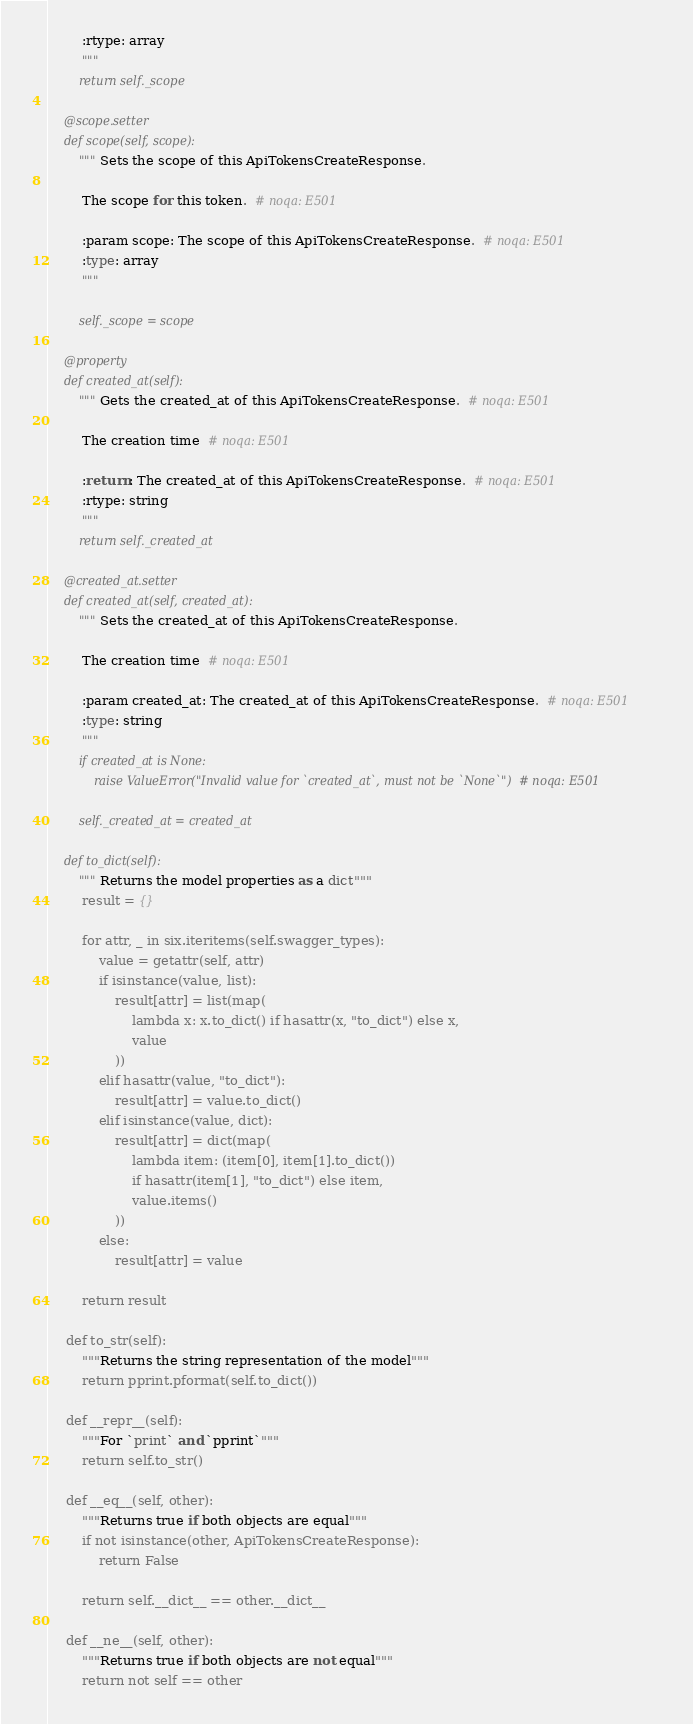<code> <loc_0><loc_0><loc_500><loc_500><_Python_>        :rtype: array
        """
        return self._scope

    @scope.setter
    def scope(self, scope):
        """Sets the scope of this ApiTokensCreateResponse.

        The scope for this token.  # noqa: E501

        :param scope: The scope of this ApiTokensCreateResponse.  # noqa: E501
        :type: array
        """

        self._scope = scope

    @property
    def created_at(self):
        """Gets the created_at of this ApiTokensCreateResponse.  # noqa: E501

        The creation time  # noqa: E501

        :return: The created_at of this ApiTokensCreateResponse.  # noqa: E501
        :rtype: string
        """
        return self._created_at

    @created_at.setter
    def created_at(self, created_at):
        """Sets the created_at of this ApiTokensCreateResponse.

        The creation time  # noqa: E501

        :param created_at: The created_at of this ApiTokensCreateResponse.  # noqa: E501
        :type: string
        """
        if created_at is None:
            raise ValueError("Invalid value for `created_at`, must not be `None`")  # noqa: E501

        self._created_at = created_at

    def to_dict(self):
        """Returns the model properties as a dict"""
        result = {}

        for attr, _ in six.iteritems(self.swagger_types):
            value = getattr(self, attr)
            if isinstance(value, list):
                result[attr] = list(map(
                    lambda x: x.to_dict() if hasattr(x, "to_dict") else x,
                    value
                ))
            elif hasattr(value, "to_dict"):
                result[attr] = value.to_dict()
            elif isinstance(value, dict):
                result[attr] = dict(map(
                    lambda item: (item[0], item[1].to_dict())
                    if hasattr(item[1], "to_dict") else item,
                    value.items()
                ))
            else:
                result[attr] = value

        return result

    def to_str(self):
        """Returns the string representation of the model"""
        return pprint.pformat(self.to_dict())

    def __repr__(self):
        """For `print` and `pprint`"""
        return self.to_str()

    def __eq__(self, other):
        """Returns true if both objects are equal"""
        if not isinstance(other, ApiTokensCreateResponse):
            return False

        return self.__dict__ == other.__dict__

    def __ne__(self, other):
        """Returns true if both objects are not equal"""
        return not self == other
</code> 